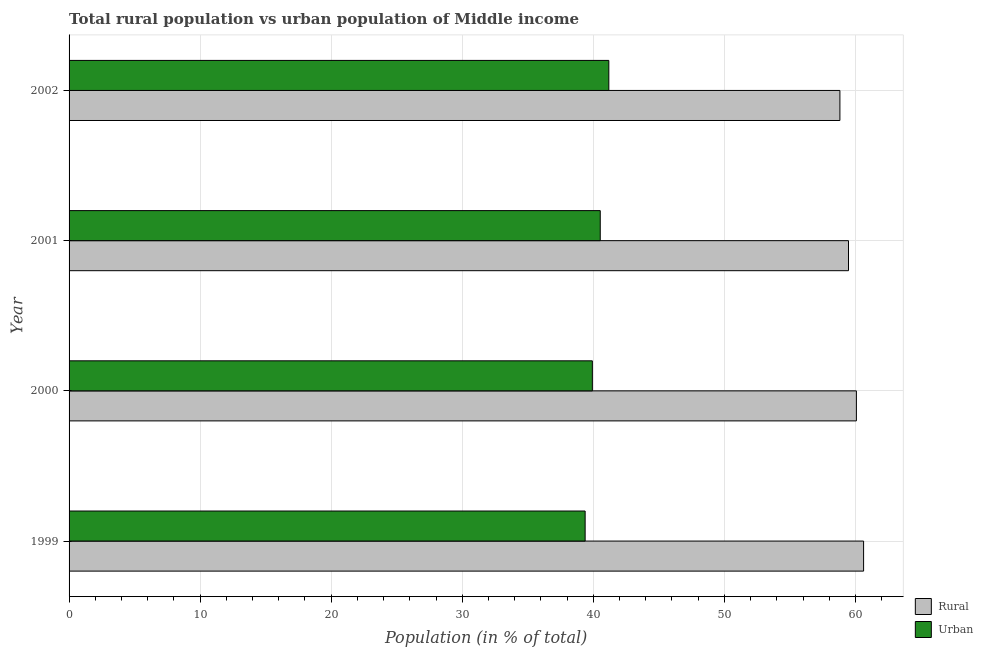How many groups of bars are there?
Offer a terse response. 4. Are the number of bars per tick equal to the number of legend labels?
Your answer should be very brief. Yes. How many bars are there on the 4th tick from the top?
Your answer should be very brief. 2. How many bars are there on the 2nd tick from the bottom?
Your answer should be compact. 2. What is the label of the 3rd group of bars from the top?
Your response must be concise. 2000. In how many cases, is the number of bars for a given year not equal to the number of legend labels?
Your answer should be compact. 0. What is the rural population in 2002?
Give a very brief answer. 58.82. Across all years, what is the maximum urban population?
Make the answer very short. 41.18. Across all years, what is the minimum rural population?
Provide a succinct answer. 58.82. In which year was the urban population minimum?
Keep it short and to the point. 1999. What is the total rural population in the graph?
Make the answer very short. 238.98. What is the difference between the rural population in 2001 and that in 2002?
Keep it short and to the point. 0.66. What is the difference between the rural population in 2002 and the urban population in 1999?
Make the answer very short. 19.44. What is the average rural population per year?
Offer a very short reply. 59.75. In the year 1999, what is the difference between the urban population and rural population?
Your answer should be compact. -21.25. In how many years, is the rural population greater than 50 %?
Offer a very short reply. 4. What is the difference between the highest and the second highest rural population?
Offer a very short reply. 0.55. What is the difference between the highest and the lowest rural population?
Ensure brevity in your answer.  1.81. What does the 1st bar from the top in 2000 represents?
Make the answer very short. Urban. What does the 1st bar from the bottom in 2001 represents?
Offer a very short reply. Rural. How many bars are there?
Offer a very short reply. 8. Are all the bars in the graph horizontal?
Provide a succinct answer. Yes. What is the difference between two consecutive major ticks on the X-axis?
Ensure brevity in your answer.  10. Are the values on the major ticks of X-axis written in scientific E-notation?
Offer a very short reply. No. Does the graph contain any zero values?
Offer a very short reply. No. How many legend labels are there?
Offer a terse response. 2. What is the title of the graph?
Your answer should be compact. Total rural population vs urban population of Middle income. Does "Urban" appear as one of the legend labels in the graph?
Your response must be concise. Yes. What is the label or title of the X-axis?
Offer a terse response. Population (in % of total). What is the label or title of the Y-axis?
Your answer should be compact. Year. What is the Population (in % of total) in Rural in 1999?
Offer a terse response. 60.62. What is the Population (in % of total) of Urban in 1999?
Your answer should be very brief. 39.38. What is the Population (in % of total) of Rural in 2000?
Make the answer very short. 60.07. What is the Population (in % of total) in Urban in 2000?
Your answer should be very brief. 39.93. What is the Population (in % of total) of Rural in 2001?
Make the answer very short. 59.47. What is the Population (in % of total) of Urban in 2001?
Your answer should be compact. 40.53. What is the Population (in % of total) of Rural in 2002?
Give a very brief answer. 58.82. What is the Population (in % of total) in Urban in 2002?
Offer a terse response. 41.18. Across all years, what is the maximum Population (in % of total) of Rural?
Offer a very short reply. 60.62. Across all years, what is the maximum Population (in % of total) of Urban?
Provide a succinct answer. 41.18. Across all years, what is the minimum Population (in % of total) of Rural?
Provide a short and direct response. 58.82. Across all years, what is the minimum Population (in % of total) in Urban?
Make the answer very short. 39.38. What is the total Population (in % of total) of Rural in the graph?
Offer a terse response. 238.98. What is the total Population (in % of total) in Urban in the graph?
Offer a very short reply. 161.02. What is the difference between the Population (in % of total) of Rural in 1999 and that in 2000?
Offer a very short reply. 0.55. What is the difference between the Population (in % of total) of Urban in 1999 and that in 2000?
Provide a short and direct response. -0.55. What is the difference between the Population (in % of total) in Rural in 1999 and that in 2001?
Your answer should be compact. 1.15. What is the difference between the Population (in % of total) in Urban in 1999 and that in 2001?
Your answer should be compact. -1.15. What is the difference between the Population (in % of total) of Rural in 1999 and that in 2002?
Provide a succinct answer. 1.81. What is the difference between the Population (in % of total) in Urban in 1999 and that in 2002?
Provide a short and direct response. -1.81. What is the difference between the Population (in % of total) in Rural in 2000 and that in 2001?
Give a very brief answer. 0.6. What is the difference between the Population (in % of total) in Urban in 2000 and that in 2001?
Your answer should be compact. -0.6. What is the difference between the Population (in % of total) of Rural in 2000 and that in 2002?
Your answer should be very brief. 1.26. What is the difference between the Population (in % of total) of Urban in 2000 and that in 2002?
Offer a very short reply. -1.26. What is the difference between the Population (in % of total) in Rural in 2001 and that in 2002?
Make the answer very short. 0.66. What is the difference between the Population (in % of total) in Urban in 2001 and that in 2002?
Provide a short and direct response. -0.66. What is the difference between the Population (in % of total) in Rural in 1999 and the Population (in % of total) in Urban in 2000?
Provide a short and direct response. 20.7. What is the difference between the Population (in % of total) in Rural in 1999 and the Population (in % of total) in Urban in 2001?
Your answer should be compact. 20.09. What is the difference between the Population (in % of total) in Rural in 1999 and the Population (in % of total) in Urban in 2002?
Offer a very short reply. 19.44. What is the difference between the Population (in % of total) of Rural in 2000 and the Population (in % of total) of Urban in 2001?
Offer a terse response. 19.54. What is the difference between the Population (in % of total) of Rural in 2000 and the Population (in % of total) of Urban in 2002?
Give a very brief answer. 18.89. What is the difference between the Population (in % of total) of Rural in 2001 and the Population (in % of total) of Urban in 2002?
Provide a short and direct response. 18.29. What is the average Population (in % of total) in Rural per year?
Provide a short and direct response. 59.75. What is the average Population (in % of total) in Urban per year?
Provide a succinct answer. 40.25. In the year 1999, what is the difference between the Population (in % of total) in Rural and Population (in % of total) in Urban?
Make the answer very short. 21.25. In the year 2000, what is the difference between the Population (in % of total) in Rural and Population (in % of total) in Urban?
Your response must be concise. 20.15. In the year 2001, what is the difference between the Population (in % of total) of Rural and Population (in % of total) of Urban?
Offer a terse response. 18.94. In the year 2002, what is the difference between the Population (in % of total) of Rural and Population (in % of total) of Urban?
Provide a short and direct response. 17.63. What is the ratio of the Population (in % of total) in Rural in 1999 to that in 2000?
Give a very brief answer. 1.01. What is the ratio of the Population (in % of total) in Urban in 1999 to that in 2000?
Offer a terse response. 0.99. What is the ratio of the Population (in % of total) of Rural in 1999 to that in 2001?
Your response must be concise. 1.02. What is the ratio of the Population (in % of total) of Urban in 1999 to that in 2001?
Keep it short and to the point. 0.97. What is the ratio of the Population (in % of total) of Rural in 1999 to that in 2002?
Your response must be concise. 1.03. What is the ratio of the Population (in % of total) of Urban in 1999 to that in 2002?
Ensure brevity in your answer.  0.96. What is the ratio of the Population (in % of total) of Rural in 2000 to that in 2001?
Offer a very short reply. 1.01. What is the ratio of the Population (in % of total) in Urban in 2000 to that in 2001?
Your response must be concise. 0.99. What is the ratio of the Population (in % of total) in Rural in 2000 to that in 2002?
Give a very brief answer. 1.02. What is the ratio of the Population (in % of total) of Urban in 2000 to that in 2002?
Offer a very short reply. 0.97. What is the ratio of the Population (in % of total) in Rural in 2001 to that in 2002?
Provide a short and direct response. 1.01. What is the ratio of the Population (in % of total) of Urban in 2001 to that in 2002?
Provide a succinct answer. 0.98. What is the difference between the highest and the second highest Population (in % of total) in Rural?
Make the answer very short. 0.55. What is the difference between the highest and the second highest Population (in % of total) of Urban?
Offer a very short reply. 0.66. What is the difference between the highest and the lowest Population (in % of total) in Rural?
Offer a terse response. 1.81. What is the difference between the highest and the lowest Population (in % of total) in Urban?
Make the answer very short. 1.81. 